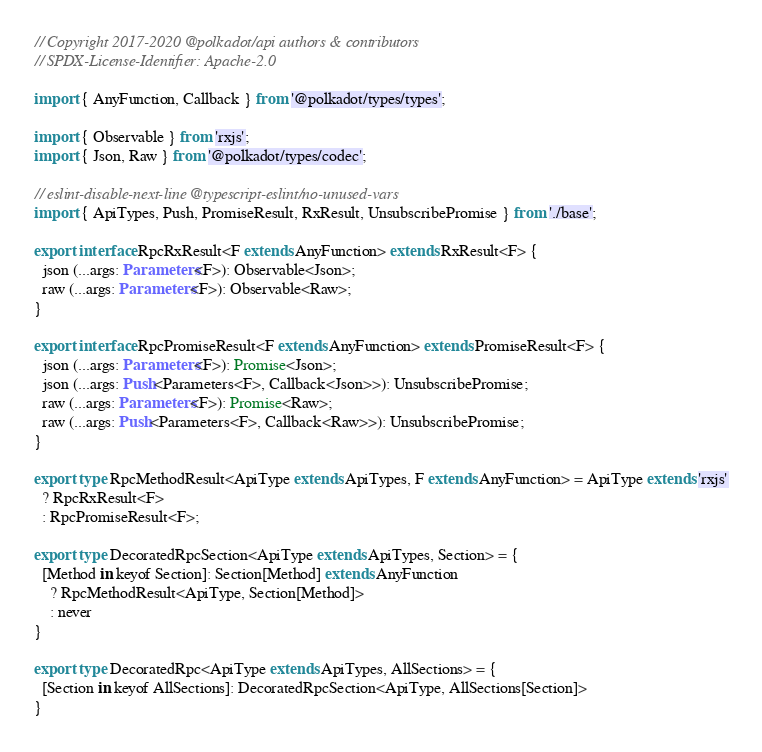Convert code to text. <code><loc_0><loc_0><loc_500><loc_500><_TypeScript_>// Copyright 2017-2020 @polkadot/api authors & contributors
// SPDX-License-Identifier: Apache-2.0

import { AnyFunction, Callback } from '@polkadot/types/types';

import { Observable } from 'rxjs';
import { Json, Raw } from '@polkadot/types/codec';

// eslint-disable-next-line @typescript-eslint/no-unused-vars
import { ApiTypes, Push, PromiseResult, RxResult, UnsubscribePromise } from './base';

export interface RpcRxResult<F extends AnyFunction> extends RxResult<F> {
  json (...args: Parameters<F>): Observable<Json>;
  raw (...args: Parameters<F>): Observable<Raw>;
}

export interface RpcPromiseResult<F extends AnyFunction> extends PromiseResult<F> {
  json (...args: Parameters<F>): Promise<Json>;
  json (...args: Push<Parameters<F>, Callback<Json>>): UnsubscribePromise;
  raw (...args: Parameters<F>): Promise<Raw>;
  raw (...args: Push<Parameters<F>, Callback<Raw>>): UnsubscribePromise;
}

export type RpcMethodResult<ApiType extends ApiTypes, F extends AnyFunction> = ApiType extends 'rxjs'
  ? RpcRxResult<F>
  : RpcPromiseResult<F>;

export type DecoratedRpcSection<ApiType extends ApiTypes, Section> = {
  [Method in keyof Section]: Section[Method] extends AnyFunction
    ? RpcMethodResult<ApiType, Section[Method]>
    : never
}

export type DecoratedRpc<ApiType extends ApiTypes, AllSections> = {
  [Section in keyof AllSections]: DecoratedRpcSection<ApiType, AllSections[Section]>
}
</code> 